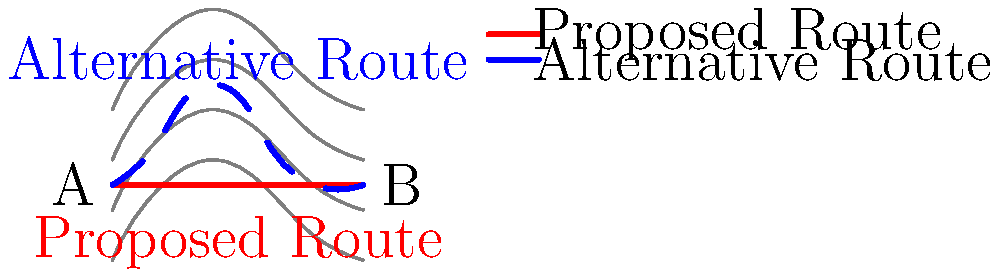Based on the topographic map shown, which route between points A and B would likely be more suitable for constructing a road, considering both construction costs and environmental impact? Explain your reasoning using principles of anthrogeography and civil engineering. To answer this question, we need to analyze the topographic map and consider the principles of anthrogeography and civil engineering. Let's break down the analysis step-by-step:

1. Terrain analysis:
   - The map shows contour lines representing elevation changes.
   - The proposed route (red line) maintains a constant elevation.
   - The alternative route (blue dashed line) follows a more varied terrain.

2. Construction costs:
   - The proposed route would require less cut-and-fill operations, as it follows a constant elevation.
   - The alternative route would involve more earthwork, increasing construction costs.

3. Environmental impact:
   - The proposed route may require more extensive modifications to the natural landscape to maintain its constant elevation.
   - The alternative route follows the natural contours more closely, potentially minimizing landscape alterations.

4. Anthrogeographic considerations:
   - The proposed route might create a barrier effect, potentially disrupting local ecosystems and human movement patterns.
   - The alternative route could better integrate with existing human and natural systems, preserving local geographic relationships.

5. Civil engineering principles:
   - The proposed route offers better grade consistency, which is beneficial for vehicle efficiency and safety.
   - The alternative route may require more complex drainage systems and erosion control measures due to its varying elevation.

6. Long-term maintenance:
   - The proposed route may be easier to maintain due to its consistent grade.
   - The alternative route might be more susceptible to erosion and weather-related damage.

7. Cultural and social factors:
   - The alternative route might better serve local communities by providing access to different elevation zones.
   - The proposed route could potentially divide communities or ecosystems.

Considering these factors, the alternative route (blue dashed line) would likely be more suitable. While it may have higher initial construction costs, it offers better integration with the natural landscape, potentially lower environmental impact, and better alignment with anthrogeographic principles. It allows for a more nuanced approach to road construction that considers both the physical and human geography of the area.
Answer: Alternative route (blue dashed line) 